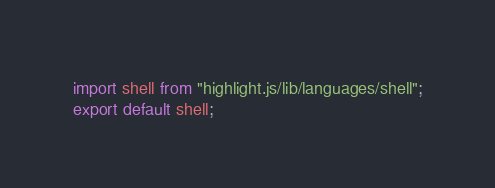<code> <loc_0><loc_0><loc_500><loc_500><_JavaScript_>import shell from "highlight.js/lib/languages/shell";
export default shell;
</code> 